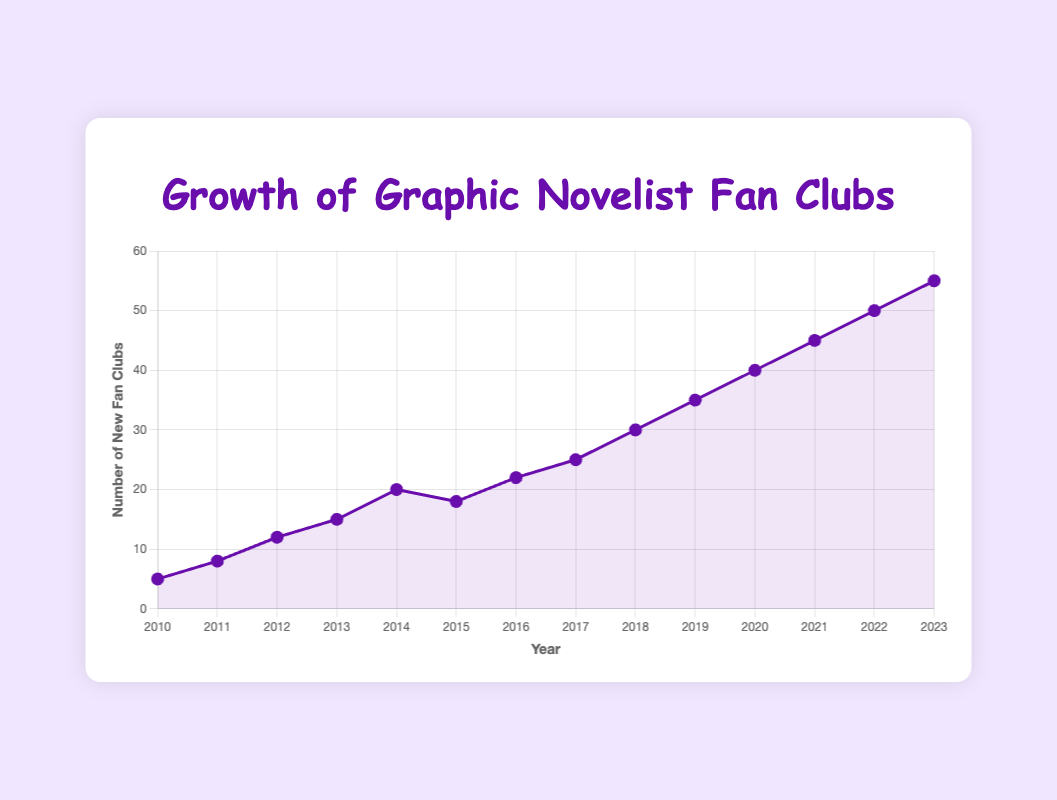What is the overall trend in the number of new fan clubs from 2010 to 2023? Observing the line plot, the number of new fan clubs has consistently increased each year from 2010 to 2023.
Answer: Increasing In which year was there a decrease in the number of new fan clubs compared to the previous year? The line plot indicates a decrease between 2014 and 2015, going from 20 to 18.
Answer: 2015 How many new fan clubs were established in the period from 2015 to 2020? Summing the values from 2015 to 2020: 18 (2015) + 22 (2016) + 25 (2017) + 30 (2018) + 35 (2019) + 40 (2020) gives 170 new fan clubs.
Answer: 170 What is the average number of new fan clubs established per year from 2010 to 2023? Adding the numbers for each year (5 + 8 + 12 + 15 + 20 + 18 + 22 + 25 + 30 + 35 + 40 + 45 + 50 + 55) gives 380. Dividing this by 14 years, the average is 380 / 14 ≈ 27.14.
Answer: 27.14 Compare the number of new fan clubs established in 2023 to 2010. How much larger is it? In 2023, 55 new fan clubs were established, compared to 5 in 2010. The difference is 55 - 5 = 50.
Answer: 50 What is the visual representation of the highest number of new fan clubs established, and in which year does it occur? The highest point on the plot represents the year 2023, indicating 55 new fan clubs.
Answer: 2023 What was the growth rate in the number of new fan clubs from 2019 to 2020? The growth rate can be calculated as ((number in 2020 - number in 2019) / number in 2019) * 100%. This is ((40 - 35) / 35) * 100% = 14.29%.
Answer: 14.29% Which two consecutive years show the highest increase in the number of new fan clubs? Comparing the differences between consecutive years, 2011 to 2012 shows the highest increase of 4 (12 - 8) and 2022 to 2023 also shows an increase of 5 (55 - 50). The latter is the largest increase.
Answer: 2022 to 2023 How did the number of new fan clubs change from 2014 to 2016? From 2014 to 2015, it decreased from 20 to 18, and then increased from 18 to 22 in 2016.
Answer: Decrease then increase By what percentage did the number of new fan clubs increase from 2010 to 2023? ((number in 2023 - number in 2010) / number in 2010) * 100% gives ((55 - 5) / 5) * 100% = 1000%.
Answer: 1000% 